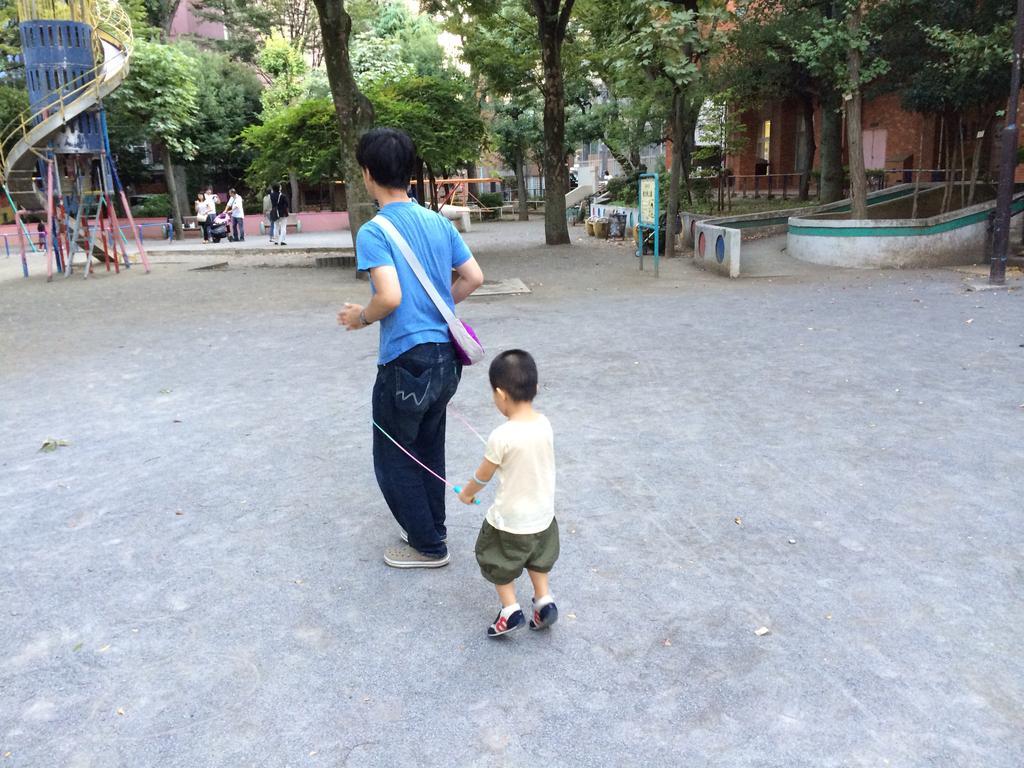How would you summarize this image in a sentence or two? This is looking like a park. In the middle of the image I can see a man and a boy running and playing on the ground. In the background, I can see few trees, few people are standing on the road and also I can see few games. 